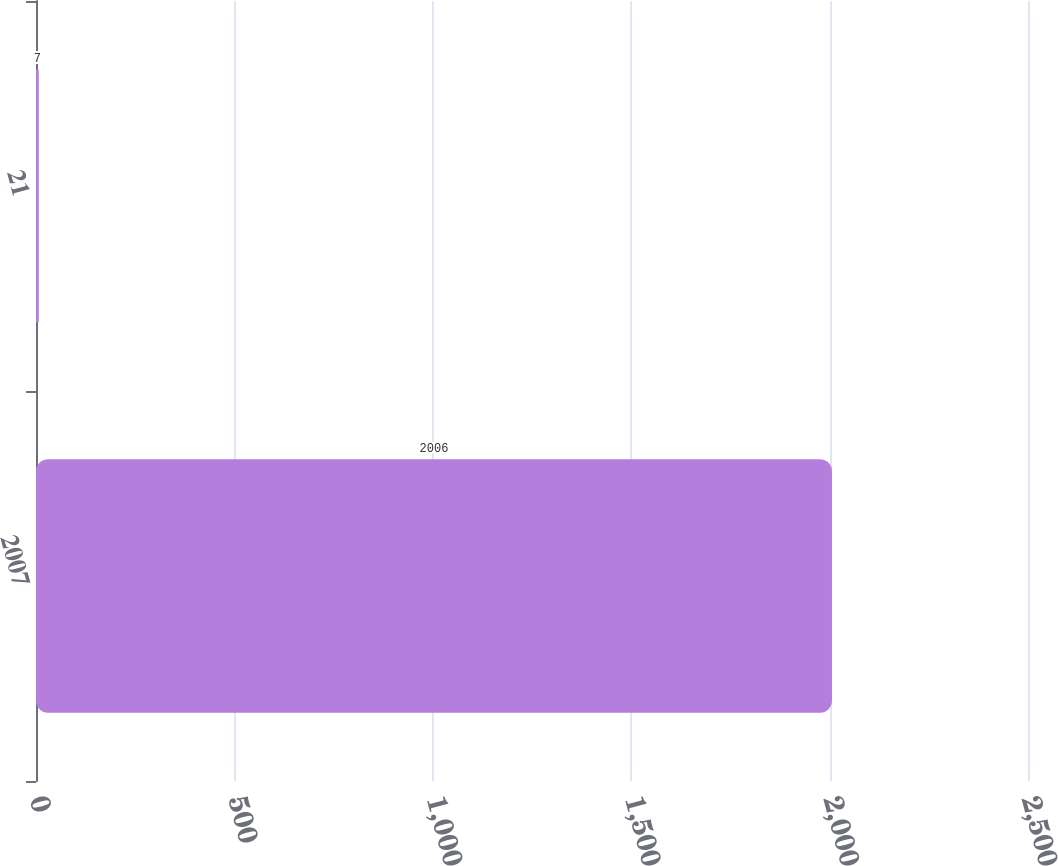<chart> <loc_0><loc_0><loc_500><loc_500><bar_chart><fcel>2007<fcel>21<nl><fcel>2006<fcel>7<nl></chart> 